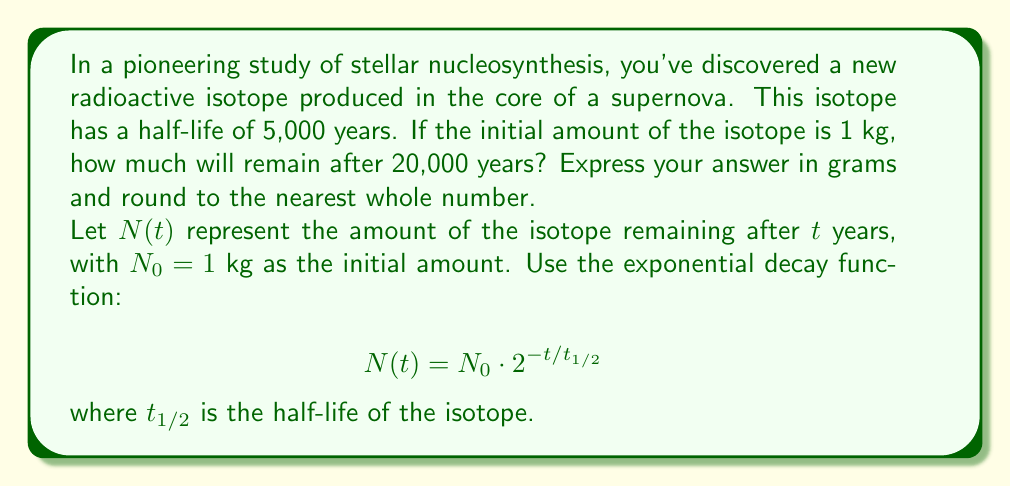Can you answer this question? To solve this problem, we'll use the exponential decay function and follow these steps:

1) We're given:
   - Initial amount $N_0 = 1$ kg
   - Half-life $t_{1/2} = 5,000$ years
   - Time elapsed $t = 20,000$ years

2) Substitute these values into the decay function:

   $$N(20000) = 1 \cdot 2^{-20000/5000}$$

3) Simplify the exponent:

   $$N(20000) = 1 \cdot 2^{-4}$$

4) Calculate:

   $$N(20000) = 1 \cdot \frac{1}{16} = 0.0625 \text{ kg}$$

5) Convert to grams:

   $$0.0625 \text{ kg} \cdot \frac{1000 \text{ g}}{1 \text{ kg}} = 62.5 \text{ g}$$

6) Round to the nearest whole number:

   $$62.5 \text{ g} \approx 63 \text{ g}$$
Answer: 63 g 